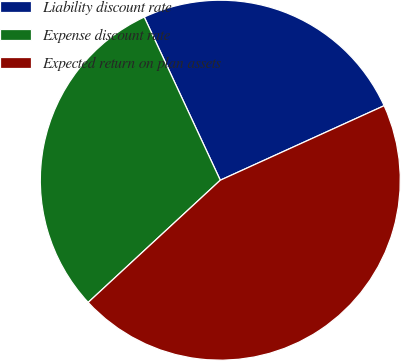Convert chart. <chart><loc_0><loc_0><loc_500><loc_500><pie_chart><fcel>Liability discount rate<fcel>Expense discount rate<fcel>Expected return on plan assets<nl><fcel>25.15%<fcel>29.94%<fcel>44.91%<nl></chart> 